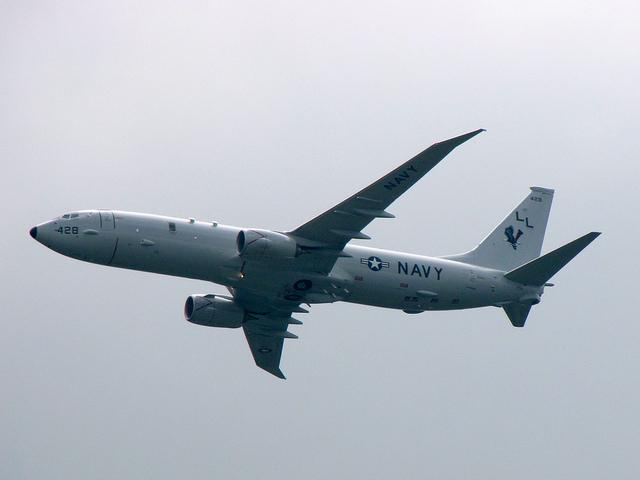What branch of the armed services owns the plane?
Short answer required. Navy. Is the airplane ascending or descending?
Write a very short answer. Ascending. Is this a passenger plane?
Write a very short answer. No. How many engines are pictured?
Be succinct. 2. Overcast or sunny?
Give a very brief answer. Overcast. What airline in this plane from?
Be succinct. Navy. 